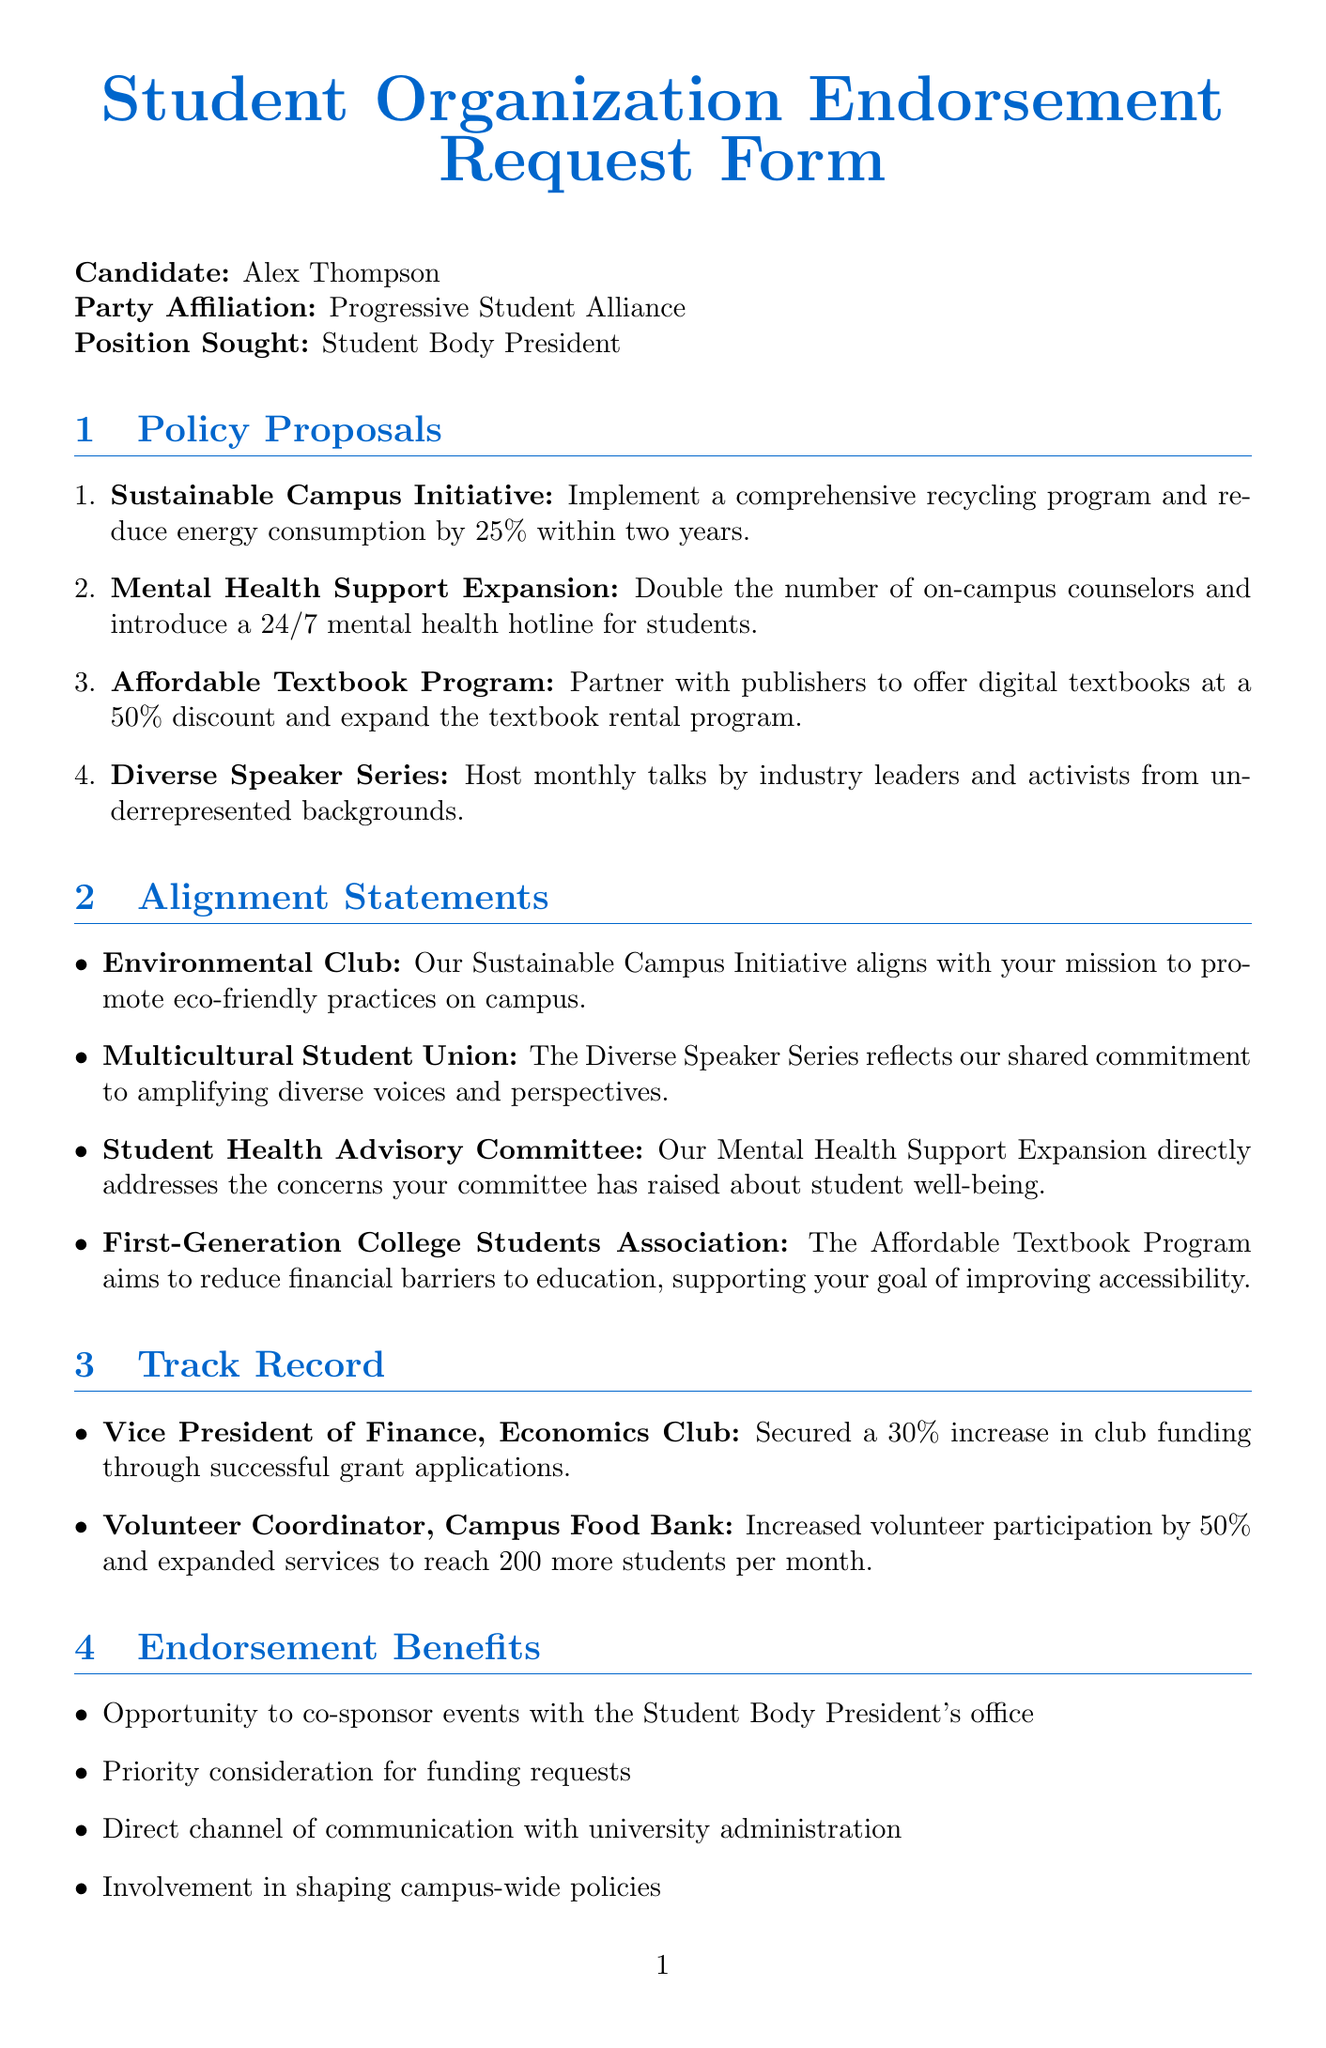what is the candidate's name? The candidate's name is provided at the beginning of the document under the candidate section.
Answer: Alex Thompson what is the position sought by the candidate? The position sought is specified in the document where the candidate's intent is highlighted.
Answer: Student Body President how many policy proposals are listed? The number of policy proposals is determined by counting each item in the policy proposals section.
Answer: 4 what is the deadline for submission of the endorsement request form? The submission deadline is clearly stated in the document.
Answer: April 15, 2023 which organization aligns with the Sustainable Campus Initiative? The alignment statements provide the organizations that share similar goals with each proposal; here, the relevant organization is noted.
Answer: Environmental Club what percentage reduction in energy consumption is proposed in the Sustainable Campus Initiative? The proposed percentage reduction is mentioned in the description of the policy proposal.
Answer: 25% how many endorsement benefits are listed? The total number of endorsement benefits can be found by enumerating the items in the endorsement benefits section.
Answer: 4 which program aims to reduce financial barriers to education? The description of this program can be found among the policy proposals; it aims to address financial accessibility.
Answer: Affordable Textbook Program who is the representative for the Student Health Advisory Committee? The organization mentioned alongside the Mental Health Support Expansion proposal can identify its focus.
Answer: Student Health Advisory Committee 